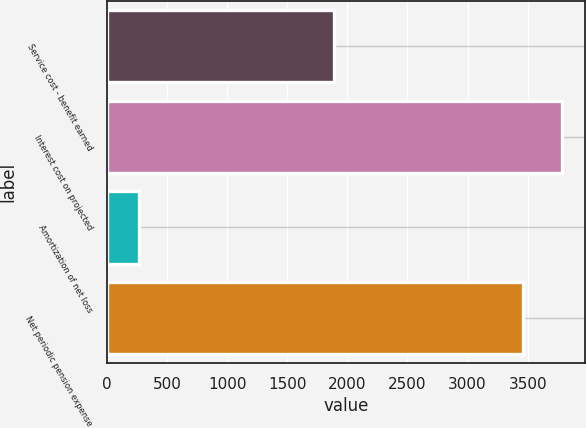Convert chart. <chart><loc_0><loc_0><loc_500><loc_500><bar_chart><fcel>Service cost - benefit earned<fcel>Interest cost on projected<fcel>Amortization of net loss<fcel>Net periodic pension expense<nl><fcel>1892<fcel>3784<fcel>269<fcel>3459<nl></chart> 